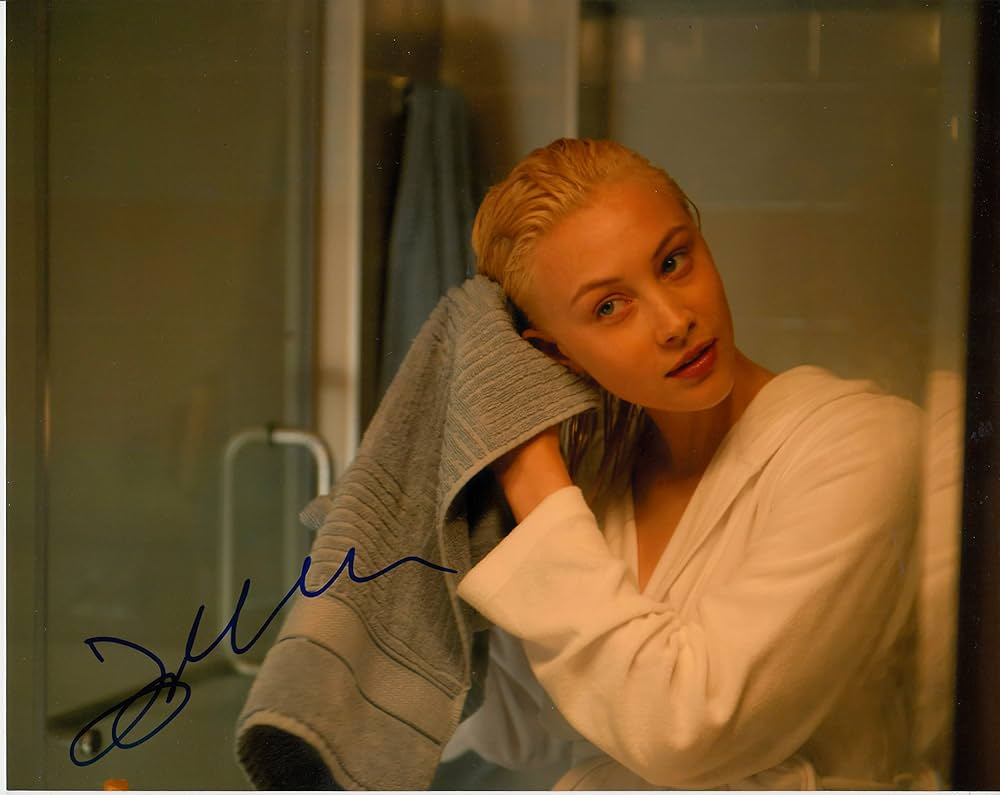What emotions does the expression of the woman in the image convey? The woman's expression in the image conveys a blend of serenity and contemplation. Her direct gaze and slight, ambiguous smile may suggest a moment of introspection or quiet confidence. The overall mood is calm, with the warm lighting and cozy attire adding to the reflective ambiance. 